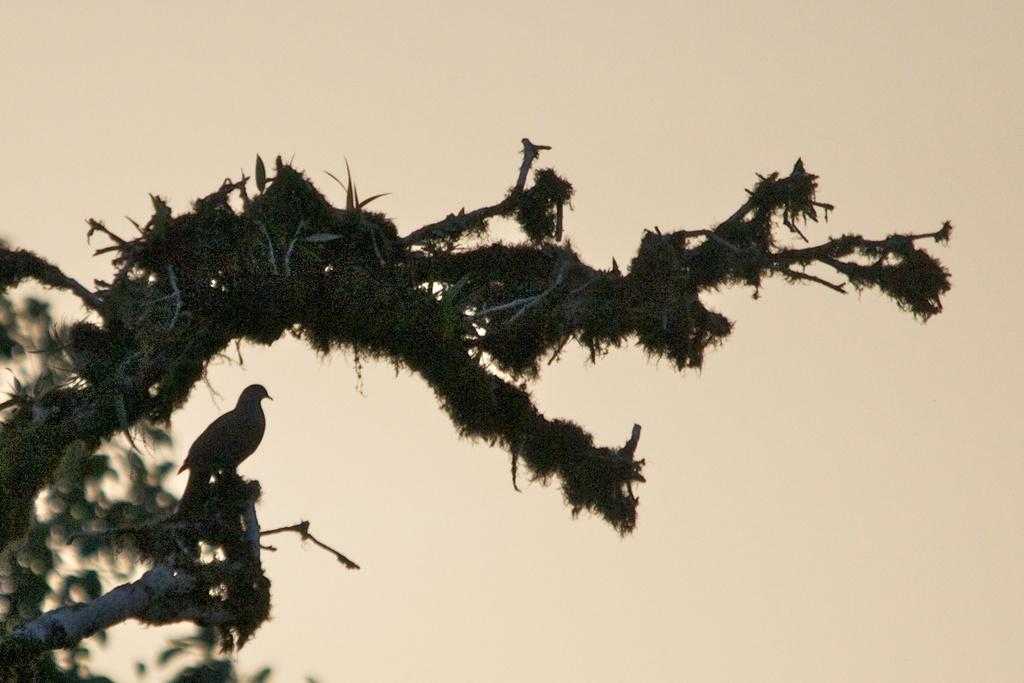What type of animal can be seen on the tree in the image? There is a bird on the tree in the image. Where is the tree located in the image? The tree is on the right side of the image. What can be seen in the background of the image? The sky is visible in the background of the image. How many men are walking on the trail in the image? There are no men or trails present in the image; it features a bird on a tree with a visible sky in the background. 